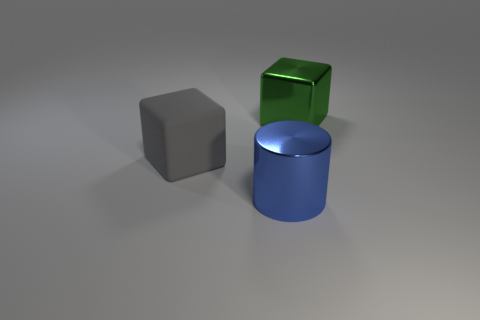What materials do the objects in the image seem to be made of? The objects appear to be rendered with different materials. The grey one has a matte finish that looks like stone or dull metal, the green is more reflective, which is indicative of a polished metallic surface, and the blue has a glossy appearance, suggesting it could be plastic or painted metal. 